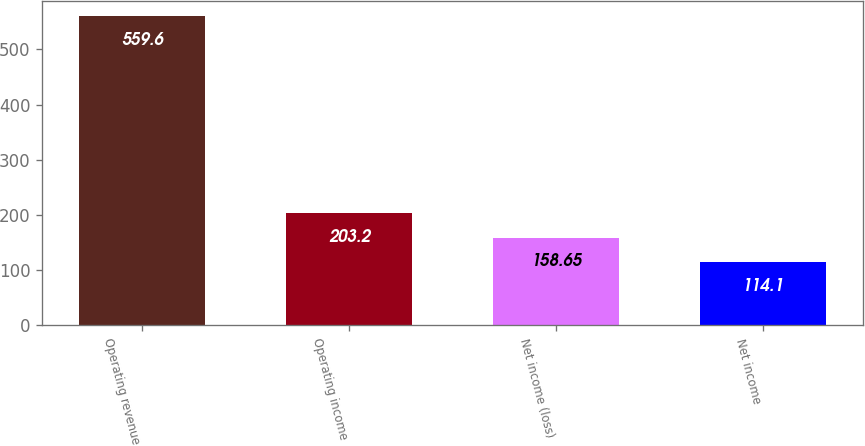<chart> <loc_0><loc_0><loc_500><loc_500><bar_chart><fcel>Operating revenue<fcel>Operating income<fcel>Net income (loss)<fcel>Net income<nl><fcel>559.6<fcel>203.2<fcel>158.65<fcel>114.1<nl></chart> 